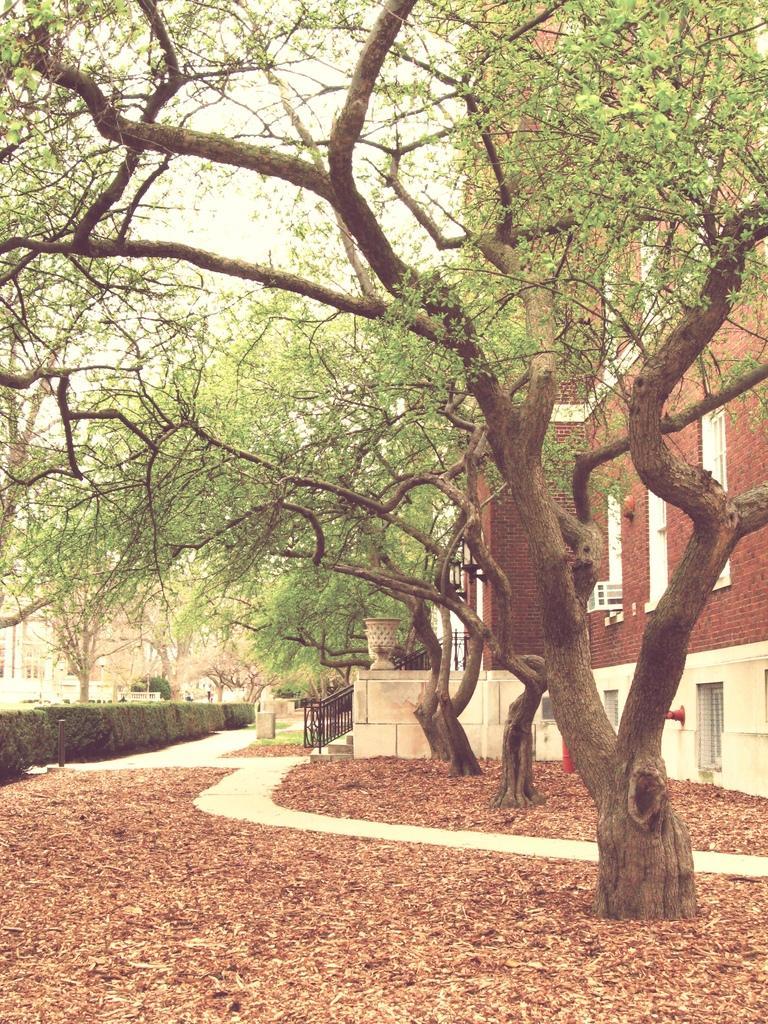Describe this image in one or two sentences. In this image there are trees, bushes and buildings, in front of the bushes there is metal fence, and there are dry leaves on the surface. 